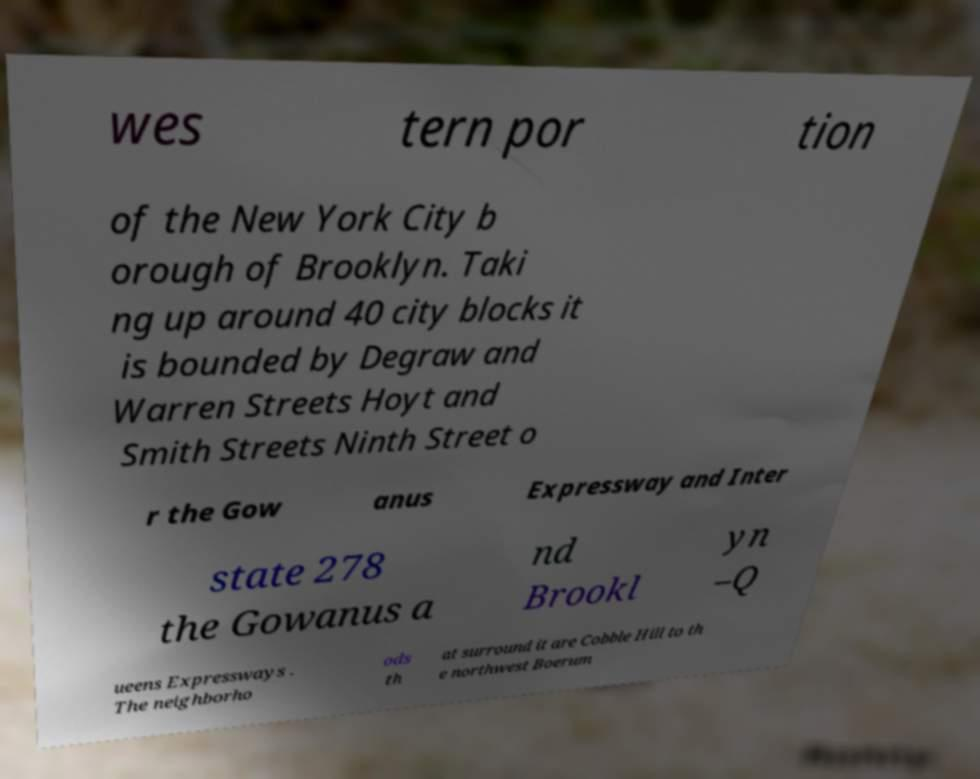What messages or text are displayed in this image? I need them in a readable, typed format. wes tern por tion of the New York City b orough of Brooklyn. Taki ng up around 40 city blocks it is bounded by Degraw and Warren Streets Hoyt and Smith Streets Ninth Street o r the Gow anus Expressway and Inter state 278 the Gowanus a nd Brookl yn –Q ueens Expressways . The neighborho ods th at surround it are Cobble Hill to th e northwest Boerum 